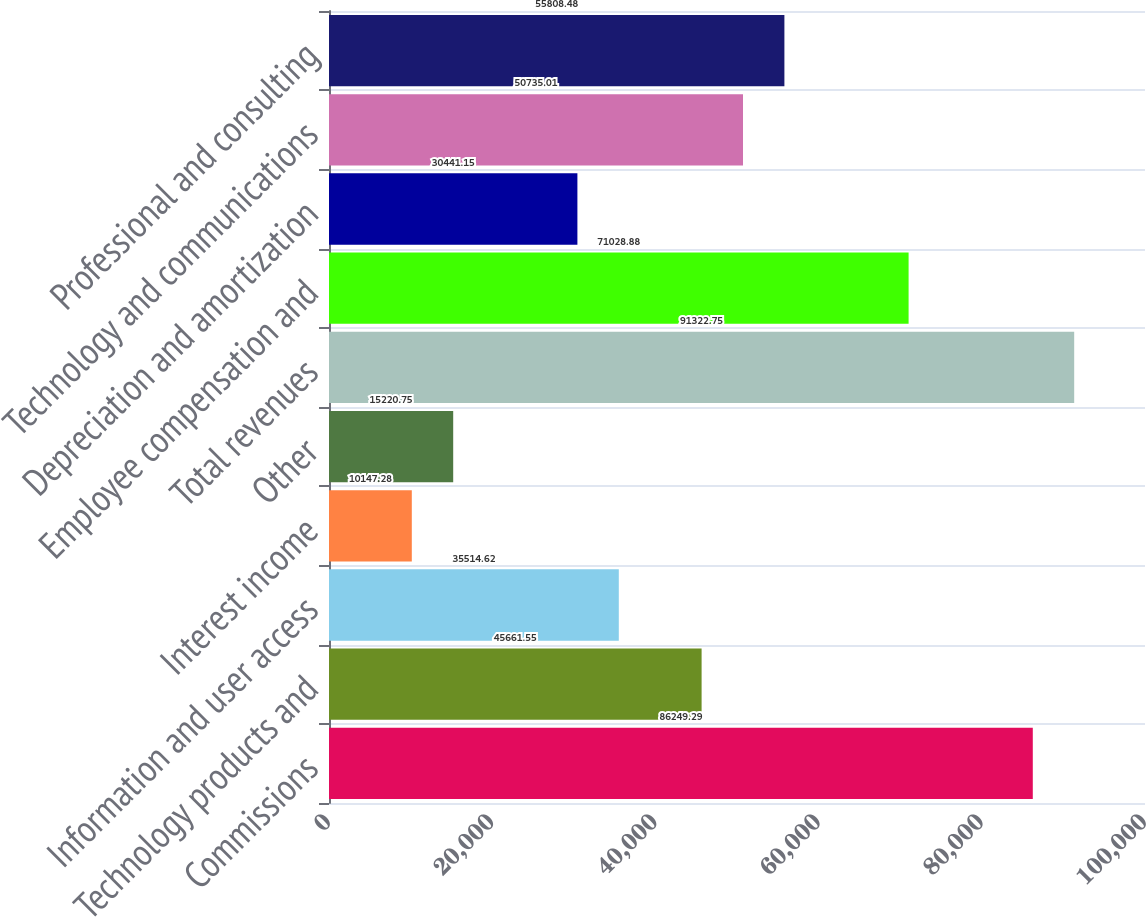Convert chart to OTSL. <chart><loc_0><loc_0><loc_500><loc_500><bar_chart><fcel>Commissions<fcel>Technology products and<fcel>Information and user access<fcel>Interest income<fcel>Other<fcel>Total revenues<fcel>Employee compensation and<fcel>Depreciation and amortization<fcel>Technology and communications<fcel>Professional and consulting<nl><fcel>86249.3<fcel>45661.6<fcel>35514.6<fcel>10147.3<fcel>15220.8<fcel>91322.8<fcel>71028.9<fcel>30441.2<fcel>50735<fcel>55808.5<nl></chart> 